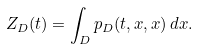<formula> <loc_0><loc_0><loc_500><loc_500>Z _ { D } ( t ) = \int _ { D } p _ { D } ( t , x , x ) \, d x .</formula> 